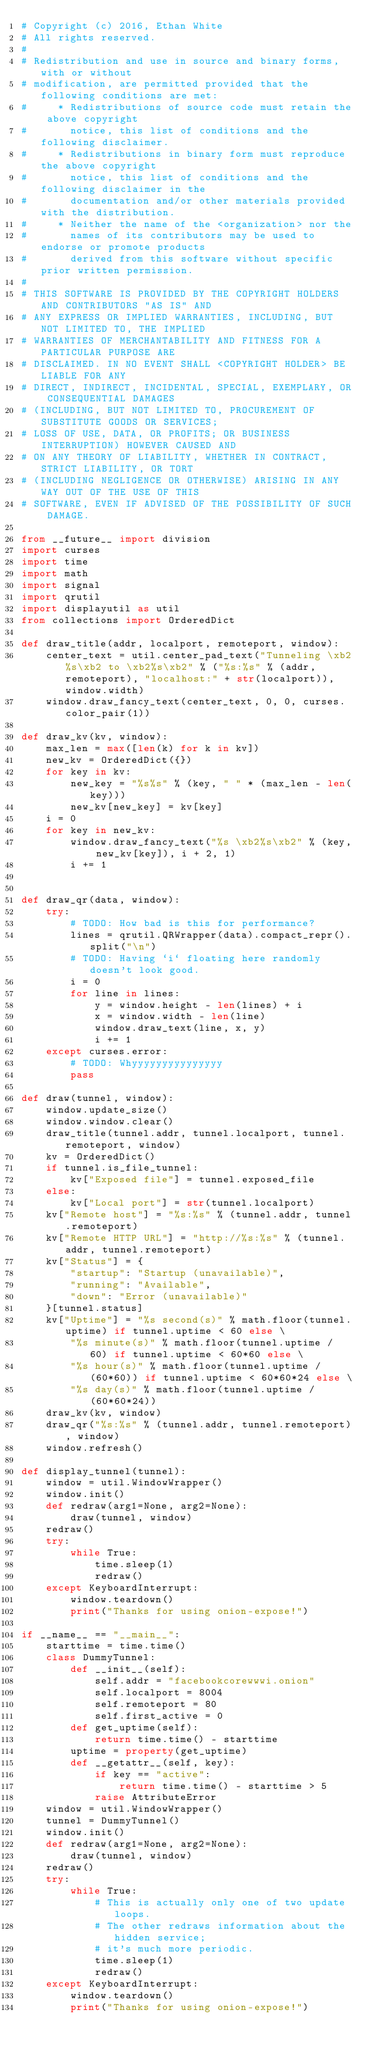<code> <loc_0><loc_0><loc_500><loc_500><_Python_># Copyright (c) 2016, Ethan White
# All rights reserved.
#
# Redistribution and use in source and binary forms, with or without
# modification, are permitted provided that the following conditions are met:
#     * Redistributions of source code must retain the above copyright
#       notice, this list of conditions and the following disclaimer.
#     * Redistributions in binary form must reproduce the above copyright
#       notice, this list of conditions and the following disclaimer in the
#       documentation and/or other materials provided with the distribution.
#     * Neither the name of the <organization> nor the
#       names of its contributors may be used to endorse or promote products
#       derived from this software without specific prior written permission.
#
# THIS SOFTWARE IS PROVIDED BY THE COPYRIGHT HOLDERS AND CONTRIBUTORS "AS IS" AND
# ANY EXPRESS OR IMPLIED WARRANTIES, INCLUDING, BUT NOT LIMITED TO, THE IMPLIED
# WARRANTIES OF MERCHANTABILITY AND FITNESS FOR A PARTICULAR PURPOSE ARE
# DISCLAIMED. IN NO EVENT SHALL <COPYRIGHT HOLDER> BE LIABLE FOR ANY
# DIRECT, INDIRECT, INCIDENTAL, SPECIAL, EXEMPLARY, OR CONSEQUENTIAL DAMAGES
# (INCLUDING, BUT NOT LIMITED TO, PROCUREMENT OF SUBSTITUTE GOODS OR SERVICES;
# LOSS OF USE, DATA, OR PROFITS; OR BUSINESS INTERRUPTION) HOWEVER CAUSED AND
# ON ANY THEORY OF LIABILITY, WHETHER IN CONTRACT, STRICT LIABILITY, OR TORT
# (INCLUDING NEGLIGENCE OR OTHERWISE) ARISING IN ANY WAY OUT OF THE USE OF THIS
# SOFTWARE, EVEN IF ADVISED OF THE POSSIBILITY OF SUCH DAMAGE.

from __future__ import division
import curses
import time
import math
import signal
import qrutil
import displayutil as util
from collections import OrderedDict

def draw_title(addr, localport, remoteport, window):
    center_text = util.center_pad_text("Tunneling \xb2%s\xb2 to \xb2%s\xb2" % ("%s:%s" % (addr, remoteport), "localhost:" + str(localport)), window.width)
    window.draw_fancy_text(center_text, 0, 0, curses.color_pair(1))

def draw_kv(kv, window):
    max_len = max([len(k) for k in kv])
    new_kv = OrderedDict({})
    for key in kv:
        new_key = "%s%s" % (key, " " * (max_len - len(key)))
        new_kv[new_key] = kv[key]
    i = 0
    for key in new_kv:
        window.draw_fancy_text("%s \xb2%s\xb2" % (key, new_kv[key]), i + 2, 1)
        i += 1


def draw_qr(data, window):
    try:
        # TODO: How bad is this for performance?
        lines = qrutil.QRWrapper(data).compact_repr().split("\n")
        # TODO: Having `i` floating here randomly doesn't look good.
        i = 0
        for line in lines:
            y = window.height - len(lines) + i
            x = window.width - len(line)
            window.draw_text(line, x, y)
            i += 1
    except curses.error:
        # TODO: Whyyyyyyyyyyyyyyy
        pass

def draw(tunnel, window):
    window.update_size()
    window.window.clear()
    draw_title(tunnel.addr, tunnel.localport, tunnel.remoteport, window)
    kv = OrderedDict()
    if tunnel.is_file_tunnel:
        kv["Exposed file"] = tunnel.exposed_file
    else:
        kv["Local port"] = str(tunnel.localport)
    kv["Remote host"] = "%s:%s" % (tunnel.addr, tunnel.remoteport)
    kv["Remote HTTP URL"] = "http://%s:%s" % (tunnel.addr, tunnel.remoteport)
    kv["Status"] = {
        "startup": "Startup (unavailable)",
        "running": "Available",
        "down": "Error (unavailable)"
    }[tunnel.status]
    kv["Uptime"] = "%s second(s)" % math.floor(tunnel.uptime) if tunnel.uptime < 60 else \
        "%s minute(s)" % math.floor(tunnel.uptime / 60) if tunnel.uptime < 60*60 else \
        "%s hour(s)" % math.floor(tunnel.uptime / (60*60)) if tunnel.uptime < 60*60*24 else \
        "%s day(s)" % math.floor(tunnel.uptime / (60*60*24))
    draw_kv(kv, window)
    draw_qr("%s:%s" % (tunnel.addr, tunnel.remoteport), window)
    window.refresh()

def display_tunnel(tunnel):
    window = util.WindowWrapper()
    window.init()
    def redraw(arg1=None, arg2=None):
        draw(tunnel, window)
    redraw()
    try:
        while True:
            time.sleep(1)
            redraw()
    except KeyboardInterrupt:
        window.teardown()
        print("Thanks for using onion-expose!")

if __name__ == "__main__":
    starttime = time.time()
    class DummyTunnel:
        def __init__(self):
            self.addr = "facebookcorewwwi.onion"
            self.localport = 8004
            self.remoteport = 80
            self.first_active = 0
        def get_uptime(self):
            return time.time() - starttime
        uptime = property(get_uptime)
        def __getattr__(self, key):
            if key == "active":
                return time.time() - starttime > 5
            raise AttributeError
    window = util.WindowWrapper()
    tunnel = DummyTunnel()
    window.init()
    def redraw(arg1=None, arg2=None):
        draw(tunnel, window)
    redraw()
    try:
        while True:
            # This is actually only one of two update loops.
            # The other redraws information about the hidden service;
            # it's much more periodic.
            time.sleep(1)
            redraw()
    except KeyboardInterrupt:
        window.teardown()
        print("Thanks for using onion-expose!")
</code> 